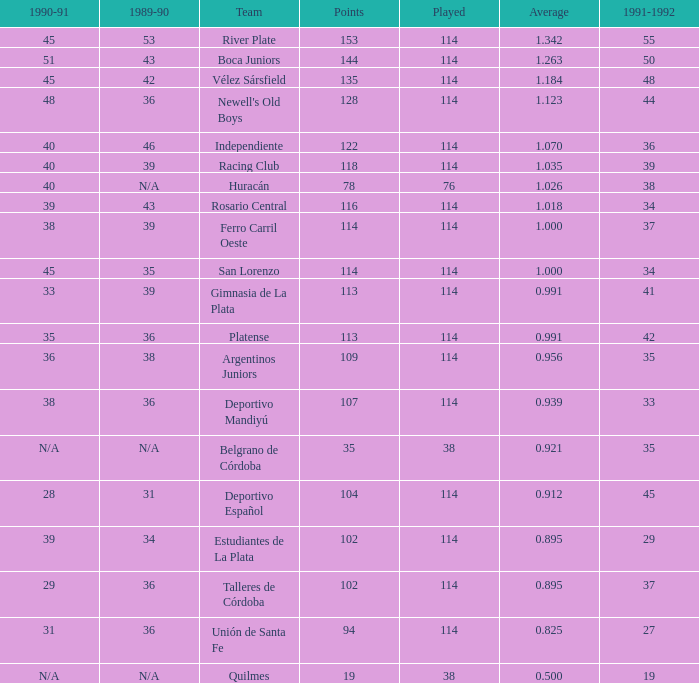How much Average has a 1989-90 of 36, and a Team of talleres de córdoba, and a Played smaller than 114? 0.0. 